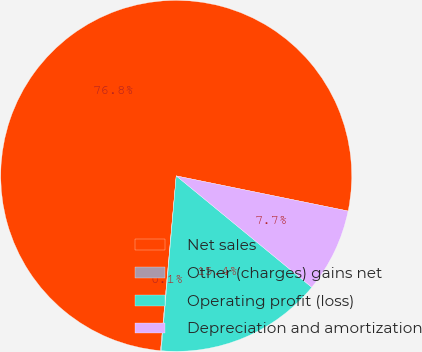Convert chart. <chart><loc_0><loc_0><loc_500><loc_500><pie_chart><fcel>Net sales<fcel>Other (charges) gains net<fcel>Operating profit (loss)<fcel>Depreciation and amortization<nl><fcel>76.79%<fcel>0.06%<fcel>15.41%<fcel>7.74%<nl></chart> 